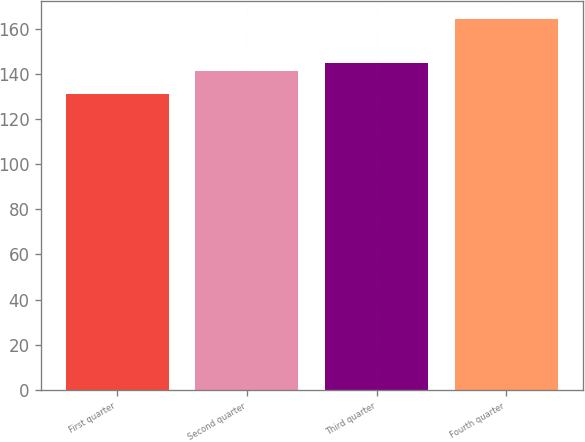Convert chart to OTSL. <chart><loc_0><loc_0><loc_500><loc_500><bar_chart><fcel>First quarter<fcel>Second quarter<fcel>Third quarter<fcel>Fourth quarter<nl><fcel>131.1<fcel>141.31<fcel>144.6<fcel>164<nl></chart> 